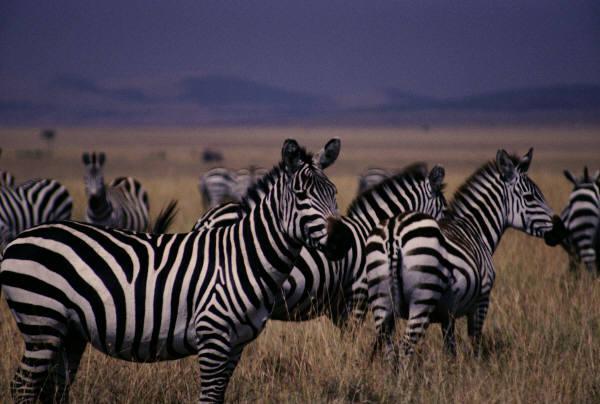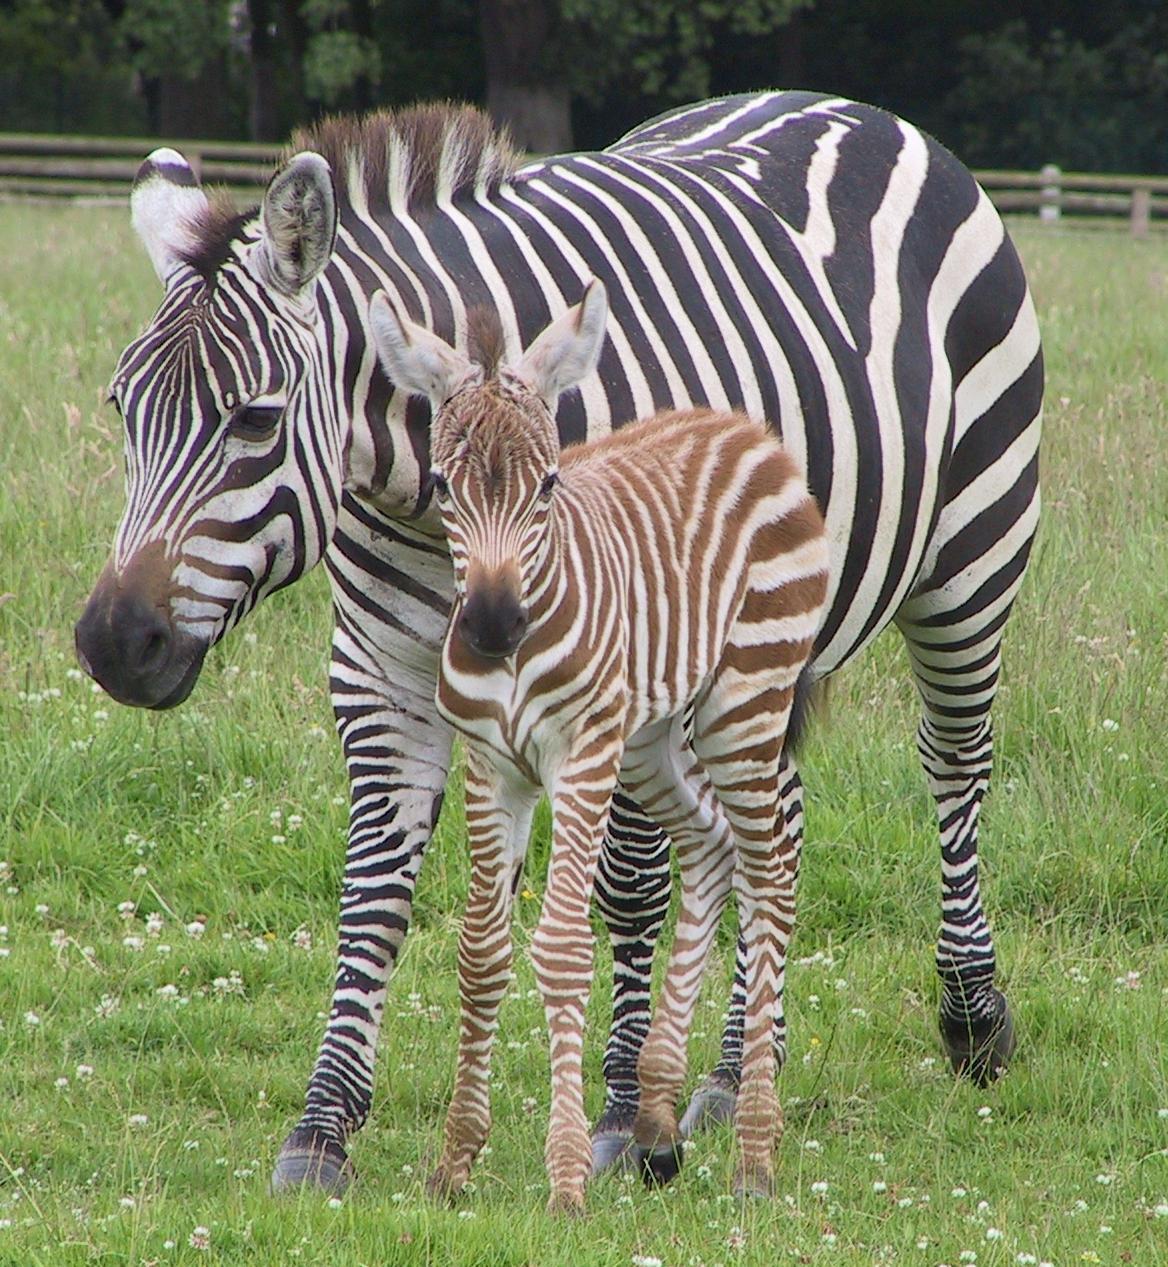The first image is the image on the left, the second image is the image on the right. Evaluate the accuracy of this statement regarding the images: "The left image features a row of no more than seven zebras with bodies mostly parallel to one another and heads raised, and the right image includes zebras with lowered heads.". Is it true? Answer yes or no. No. The first image is the image on the left, the second image is the image on the right. Assess this claim about the two images: "The right image contains exactly two zebras.". Correct or not? Answer yes or no. Yes. 